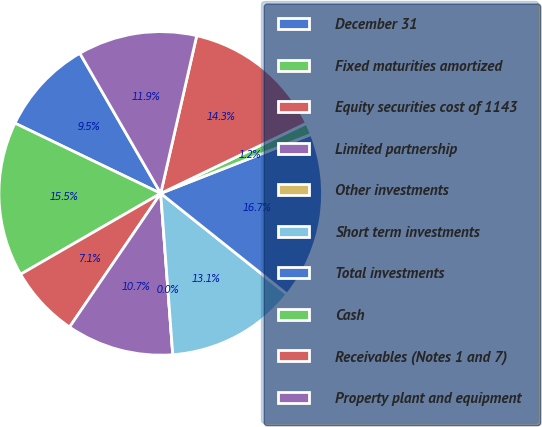Convert chart. <chart><loc_0><loc_0><loc_500><loc_500><pie_chart><fcel>December 31<fcel>Fixed maturities amortized<fcel>Equity securities cost of 1143<fcel>Limited partnership<fcel>Other investments<fcel>Short term investments<fcel>Total investments<fcel>Cash<fcel>Receivables (Notes 1 and 7)<fcel>Property plant and equipment<nl><fcel>9.52%<fcel>15.47%<fcel>7.14%<fcel>10.71%<fcel>0.0%<fcel>13.09%<fcel>16.66%<fcel>1.19%<fcel>14.28%<fcel>11.9%<nl></chart> 